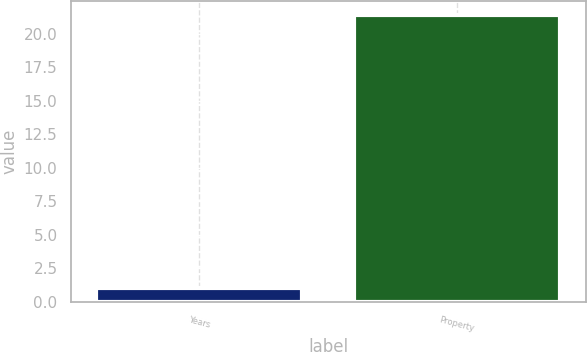Convert chart. <chart><loc_0><loc_0><loc_500><loc_500><bar_chart><fcel>Years<fcel>Property<nl><fcel>1<fcel>21.4<nl></chart> 